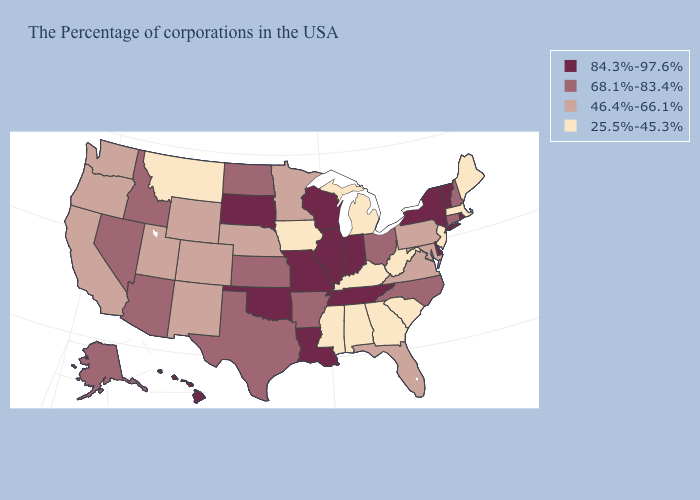Does the first symbol in the legend represent the smallest category?
Answer briefly. No. Which states hav the highest value in the South?
Short answer required. Delaware, Tennessee, Louisiana, Oklahoma. What is the value of Tennessee?
Concise answer only. 84.3%-97.6%. What is the value of Vermont?
Keep it brief. 84.3%-97.6%. Does Kentucky have the highest value in the USA?
Write a very short answer. No. What is the value of Hawaii?
Be succinct. 84.3%-97.6%. What is the lowest value in the USA?
Short answer required. 25.5%-45.3%. What is the value of Virginia?
Answer briefly. 46.4%-66.1%. What is the value of Maine?
Write a very short answer. 25.5%-45.3%. Name the states that have a value in the range 68.1%-83.4%?
Keep it brief. New Hampshire, Connecticut, North Carolina, Ohio, Arkansas, Kansas, Texas, North Dakota, Arizona, Idaho, Nevada, Alaska. What is the lowest value in states that border Oregon?
Concise answer only. 46.4%-66.1%. Does Georgia have a higher value than Kentucky?
Concise answer only. No. Which states have the highest value in the USA?
Answer briefly. Rhode Island, Vermont, New York, Delaware, Indiana, Tennessee, Wisconsin, Illinois, Louisiana, Missouri, Oklahoma, South Dakota, Hawaii. What is the highest value in states that border Kansas?
Keep it brief. 84.3%-97.6%. Name the states that have a value in the range 84.3%-97.6%?
Keep it brief. Rhode Island, Vermont, New York, Delaware, Indiana, Tennessee, Wisconsin, Illinois, Louisiana, Missouri, Oklahoma, South Dakota, Hawaii. 